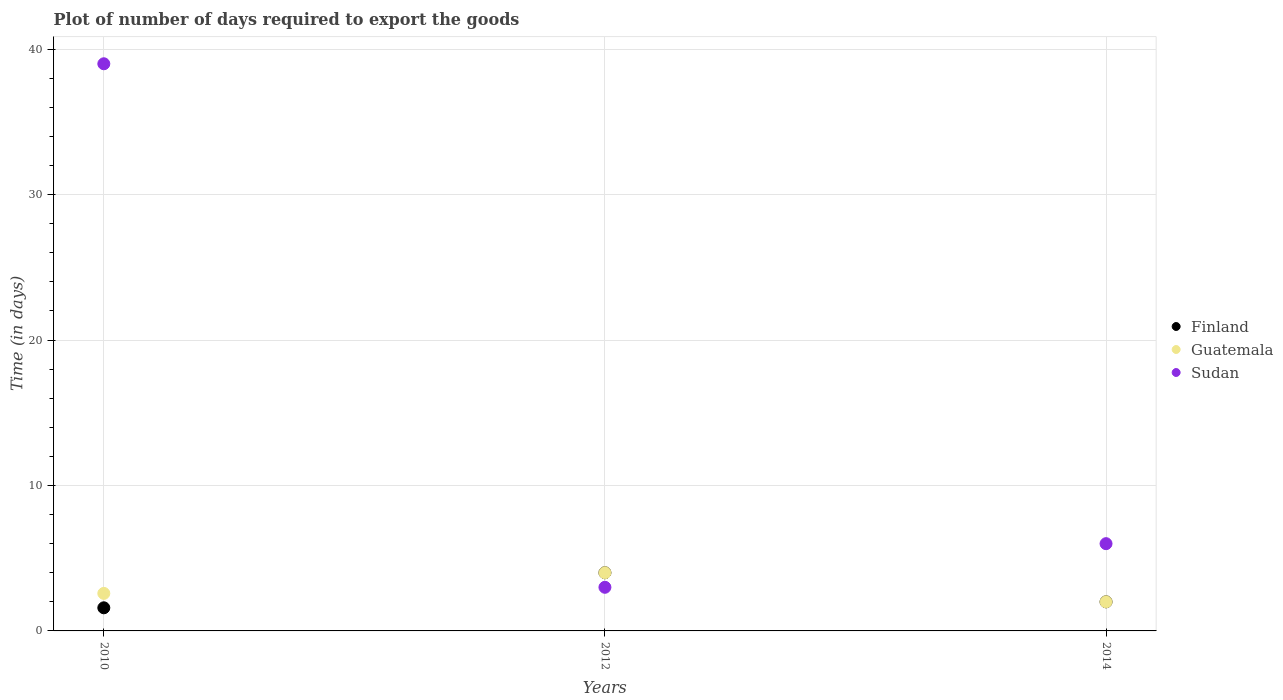How many different coloured dotlines are there?
Your answer should be compact. 3. Is the number of dotlines equal to the number of legend labels?
Give a very brief answer. Yes. What is the time required to export goods in Finland in 2014?
Provide a short and direct response. 2. Across all years, what is the minimum time required to export goods in Finland?
Keep it short and to the point. 1.59. What is the total time required to export goods in Sudan in the graph?
Offer a very short reply. 48. What is the difference between the time required to export goods in Guatemala in 2010 and that in 2014?
Your response must be concise. 0.58. What is the difference between the time required to export goods in Sudan in 2014 and the time required to export goods in Finland in 2010?
Give a very brief answer. 4.41. What is the average time required to export goods in Finland per year?
Offer a very short reply. 2.53. In the year 2012, what is the difference between the time required to export goods in Finland and time required to export goods in Sudan?
Keep it short and to the point. 1. What is the ratio of the time required to export goods in Finland in 2012 to that in 2014?
Your answer should be very brief. 2. What is the difference between the highest and the second highest time required to export goods in Sudan?
Your response must be concise. 33. Is the sum of the time required to export goods in Sudan in 2010 and 2012 greater than the maximum time required to export goods in Finland across all years?
Your response must be concise. Yes. Does the time required to export goods in Sudan monotonically increase over the years?
Ensure brevity in your answer.  No. Is the time required to export goods in Guatemala strictly less than the time required to export goods in Sudan over the years?
Offer a terse response. No. How many years are there in the graph?
Ensure brevity in your answer.  3. What is the difference between two consecutive major ticks on the Y-axis?
Your answer should be very brief. 10. Does the graph contain any zero values?
Keep it short and to the point. No. Does the graph contain grids?
Make the answer very short. Yes. Where does the legend appear in the graph?
Provide a succinct answer. Center right. How many legend labels are there?
Make the answer very short. 3. What is the title of the graph?
Ensure brevity in your answer.  Plot of number of days required to export the goods. Does "Middle East & North Africa (developing only)" appear as one of the legend labels in the graph?
Offer a terse response. No. What is the label or title of the Y-axis?
Provide a short and direct response. Time (in days). What is the Time (in days) in Finland in 2010?
Your answer should be compact. 1.59. What is the Time (in days) in Guatemala in 2010?
Provide a succinct answer. 2.58. What is the Time (in days) of Finland in 2012?
Make the answer very short. 4. What is the Time (in days) in Guatemala in 2012?
Ensure brevity in your answer.  4. What is the Time (in days) in Sudan in 2012?
Keep it short and to the point. 3. What is the Time (in days) of Finland in 2014?
Your answer should be very brief. 2. What is the Time (in days) of Guatemala in 2014?
Give a very brief answer. 2. What is the Time (in days) in Sudan in 2014?
Provide a succinct answer. 6. Across all years, what is the maximum Time (in days) of Finland?
Make the answer very short. 4. Across all years, what is the minimum Time (in days) in Finland?
Keep it short and to the point. 1.59. What is the total Time (in days) in Finland in the graph?
Provide a short and direct response. 7.59. What is the total Time (in days) in Guatemala in the graph?
Your answer should be very brief. 8.58. What is the difference between the Time (in days) of Finland in 2010 and that in 2012?
Ensure brevity in your answer.  -2.41. What is the difference between the Time (in days) of Guatemala in 2010 and that in 2012?
Provide a succinct answer. -1.42. What is the difference between the Time (in days) of Sudan in 2010 and that in 2012?
Give a very brief answer. 36. What is the difference between the Time (in days) of Finland in 2010 and that in 2014?
Provide a short and direct response. -0.41. What is the difference between the Time (in days) of Guatemala in 2010 and that in 2014?
Offer a terse response. 0.58. What is the difference between the Time (in days) of Sudan in 2010 and that in 2014?
Make the answer very short. 33. What is the difference between the Time (in days) in Finland in 2012 and that in 2014?
Make the answer very short. 2. What is the difference between the Time (in days) of Finland in 2010 and the Time (in days) of Guatemala in 2012?
Give a very brief answer. -2.41. What is the difference between the Time (in days) of Finland in 2010 and the Time (in days) of Sudan in 2012?
Your answer should be very brief. -1.41. What is the difference between the Time (in days) in Guatemala in 2010 and the Time (in days) in Sudan in 2012?
Your answer should be compact. -0.42. What is the difference between the Time (in days) of Finland in 2010 and the Time (in days) of Guatemala in 2014?
Offer a very short reply. -0.41. What is the difference between the Time (in days) of Finland in 2010 and the Time (in days) of Sudan in 2014?
Provide a succinct answer. -4.41. What is the difference between the Time (in days) of Guatemala in 2010 and the Time (in days) of Sudan in 2014?
Your response must be concise. -3.42. What is the difference between the Time (in days) of Finland in 2012 and the Time (in days) of Guatemala in 2014?
Ensure brevity in your answer.  2. What is the difference between the Time (in days) of Finland in 2012 and the Time (in days) of Sudan in 2014?
Provide a short and direct response. -2. What is the difference between the Time (in days) of Guatemala in 2012 and the Time (in days) of Sudan in 2014?
Give a very brief answer. -2. What is the average Time (in days) in Finland per year?
Ensure brevity in your answer.  2.53. What is the average Time (in days) in Guatemala per year?
Your answer should be compact. 2.86. What is the average Time (in days) in Sudan per year?
Offer a terse response. 16. In the year 2010, what is the difference between the Time (in days) of Finland and Time (in days) of Guatemala?
Your answer should be compact. -0.99. In the year 2010, what is the difference between the Time (in days) of Finland and Time (in days) of Sudan?
Keep it short and to the point. -37.41. In the year 2010, what is the difference between the Time (in days) in Guatemala and Time (in days) in Sudan?
Keep it short and to the point. -36.42. In the year 2012, what is the difference between the Time (in days) in Finland and Time (in days) in Sudan?
Make the answer very short. 1. What is the ratio of the Time (in days) in Finland in 2010 to that in 2012?
Ensure brevity in your answer.  0.4. What is the ratio of the Time (in days) in Guatemala in 2010 to that in 2012?
Your answer should be compact. 0.65. What is the ratio of the Time (in days) of Finland in 2010 to that in 2014?
Provide a short and direct response. 0.8. What is the ratio of the Time (in days) in Guatemala in 2010 to that in 2014?
Offer a very short reply. 1.29. What is the ratio of the Time (in days) in Sudan in 2010 to that in 2014?
Offer a terse response. 6.5. What is the difference between the highest and the second highest Time (in days) of Finland?
Ensure brevity in your answer.  2. What is the difference between the highest and the second highest Time (in days) in Guatemala?
Keep it short and to the point. 1.42. What is the difference between the highest and the second highest Time (in days) of Sudan?
Your response must be concise. 33. What is the difference between the highest and the lowest Time (in days) of Finland?
Offer a very short reply. 2.41. What is the difference between the highest and the lowest Time (in days) in Sudan?
Your answer should be very brief. 36. 